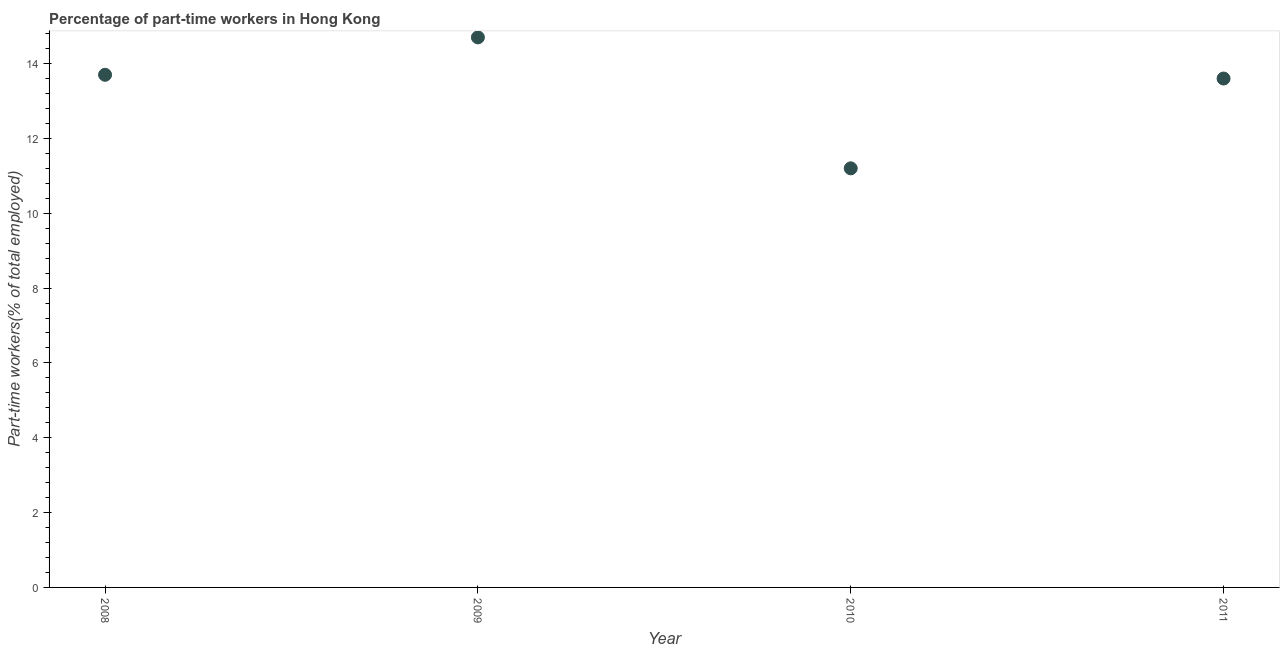What is the percentage of part-time workers in 2011?
Give a very brief answer. 13.6. Across all years, what is the maximum percentage of part-time workers?
Provide a short and direct response. 14.7. Across all years, what is the minimum percentage of part-time workers?
Keep it short and to the point. 11.2. In which year was the percentage of part-time workers maximum?
Make the answer very short. 2009. In which year was the percentage of part-time workers minimum?
Provide a short and direct response. 2010. What is the sum of the percentage of part-time workers?
Offer a terse response. 53.2. What is the difference between the percentage of part-time workers in 2010 and 2011?
Keep it short and to the point. -2.4. What is the average percentage of part-time workers per year?
Your answer should be very brief. 13.3. What is the median percentage of part-time workers?
Make the answer very short. 13.65. In how many years, is the percentage of part-time workers greater than 14.4 %?
Keep it short and to the point. 1. Do a majority of the years between 2008 and 2011 (inclusive) have percentage of part-time workers greater than 12.4 %?
Give a very brief answer. Yes. What is the ratio of the percentage of part-time workers in 2008 to that in 2011?
Make the answer very short. 1.01. Is the sum of the percentage of part-time workers in 2009 and 2010 greater than the maximum percentage of part-time workers across all years?
Offer a terse response. Yes. How many dotlines are there?
Make the answer very short. 1. What is the difference between two consecutive major ticks on the Y-axis?
Make the answer very short. 2. Does the graph contain grids?
Give a very brief answer. No. What is the title of the graph?
Make the answer very short. Percentage of part-time workers in Hong Kong. What is the label or title of the Y-axis?
Give a very brief answer. Part-time workers(% of total employed). What is the Part-time workers(% of total employed) in 2008?
Give a very brief answer. 13.7. What is the Part-time workers(% of total employed) in 2009?
Provide a short and direct response. 14.7. What is the Part-time workers(% of total employed) in 2010?
Make the answer very short. 11.2. What is the Part-time workers(% of total employed) in 2011?
Offer a very short reply. 13.6. What is the difference between the Part-time workers(% of total employed) in 2008 and 2009?
Your answer should be very brief. -1. What is the difference between the Part-time workers(% of total employed) in 2008 and 2010?
Your answer should be very brief. 2.5. What is the difference between the Part-time workers(% of total employed) in 2009 and 2010?
Give a very brief answer. 3.5. What is the difference between the Part-time workers(% of total employed) in 2010 and 2011?
Give a very brief answer. -2.4. What is the ratio of the Part-time workers(% of total employed) in 2008 to that in 2009?
Provide a succinct answer. 0.93. What is the ratio of the Part-time workers(% of total employed) in 2008 to that in 2010?
Provide a short and direct response. 1.22. What is the ratio of the Part-time workers(% of total employed) in 2009 to that in 2010?
Give a very brief answer. 1.31. What is the ratio of the Part-time workers(% of total employed) in 2009 to that in 2011?
Offer a terse response. 1.08. What is the ratio of the Part-time workers(% of total employed) in 2010 to that in 2011?
Offer a terse response. 0.82. 